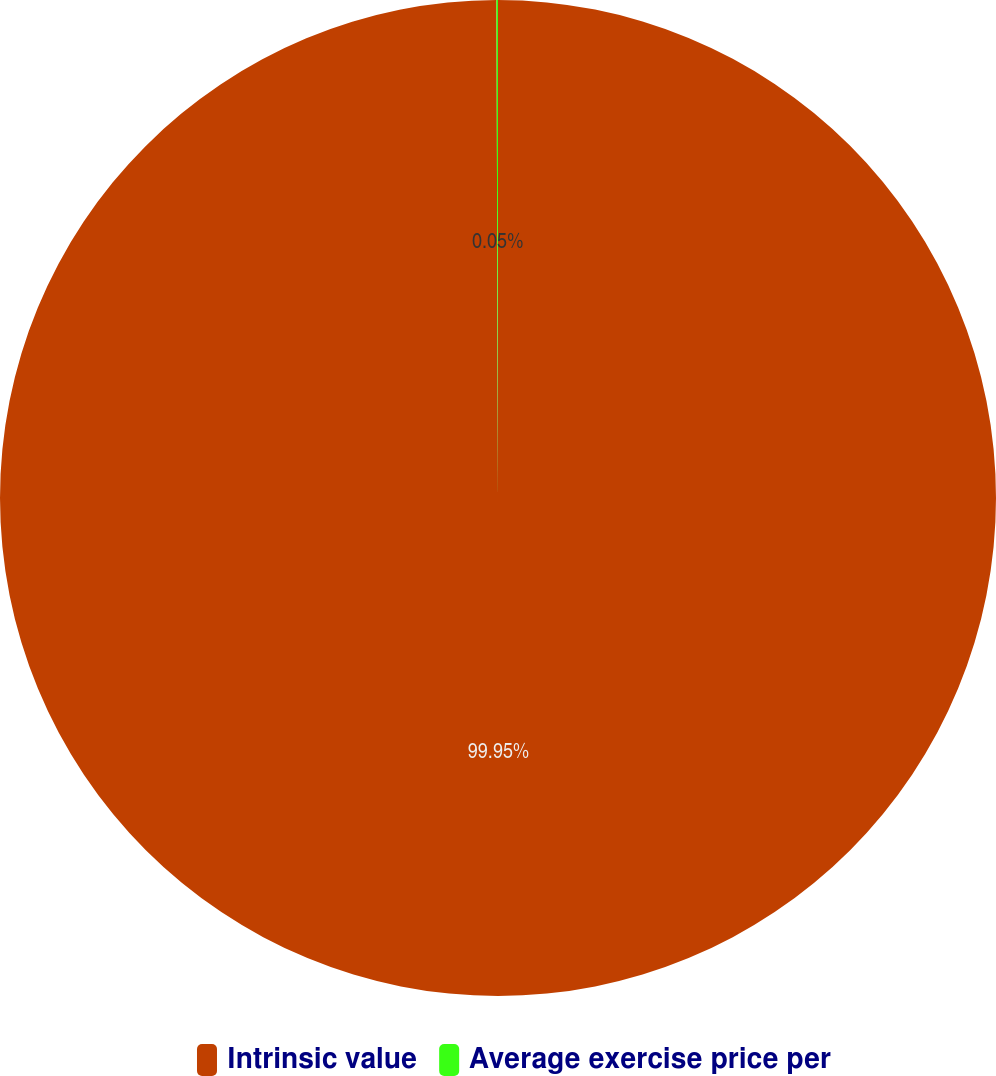<chart> <loc_0><loc_0><loc_500><loc_500><pie_chart><fcel>Intrinsic value<fcel>Average exercise price per<nl><fcel>99.95%<fcel>0.05%<nl></chart> 